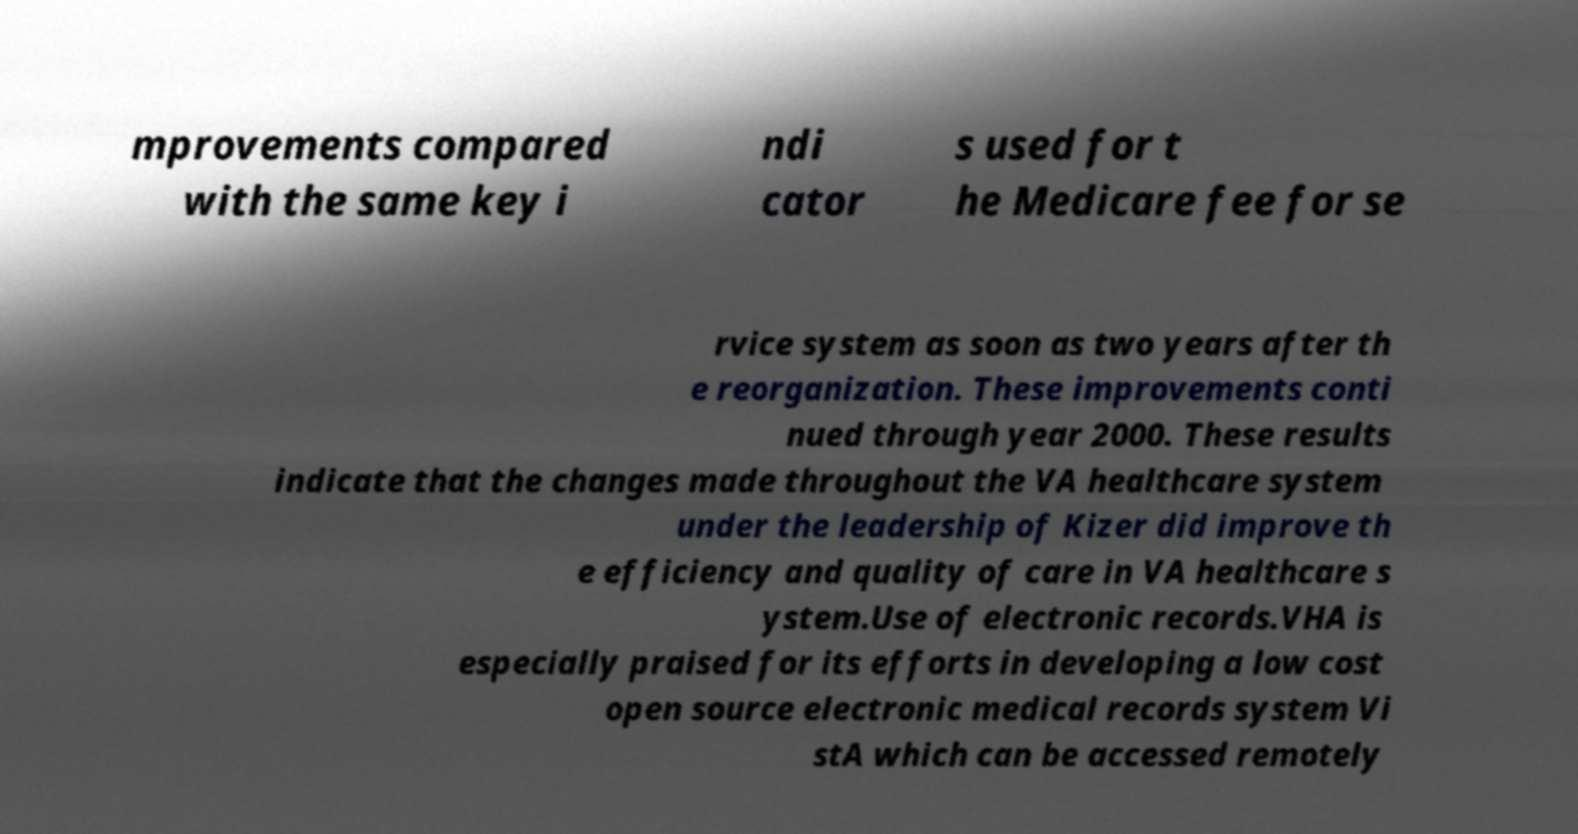For documentation purposes, I need the text within this image transcribed. Could you provide that? mprovements compared with the same key i ndi cator s used for t he Medicare fee for se rvice system as soon as two years after th e reorganization. These improvements conti nued through year 2000. These results indicate that the changes made throughout the VA healthcare system under the leadership of Kizer did improve th e efficiency and quality of care in VA healthcare s ystem.Use of electronic records.VHA is especially praised for its efforts in developing a low cost open source electronic medical records system Vi stA which can be accessed remotely 